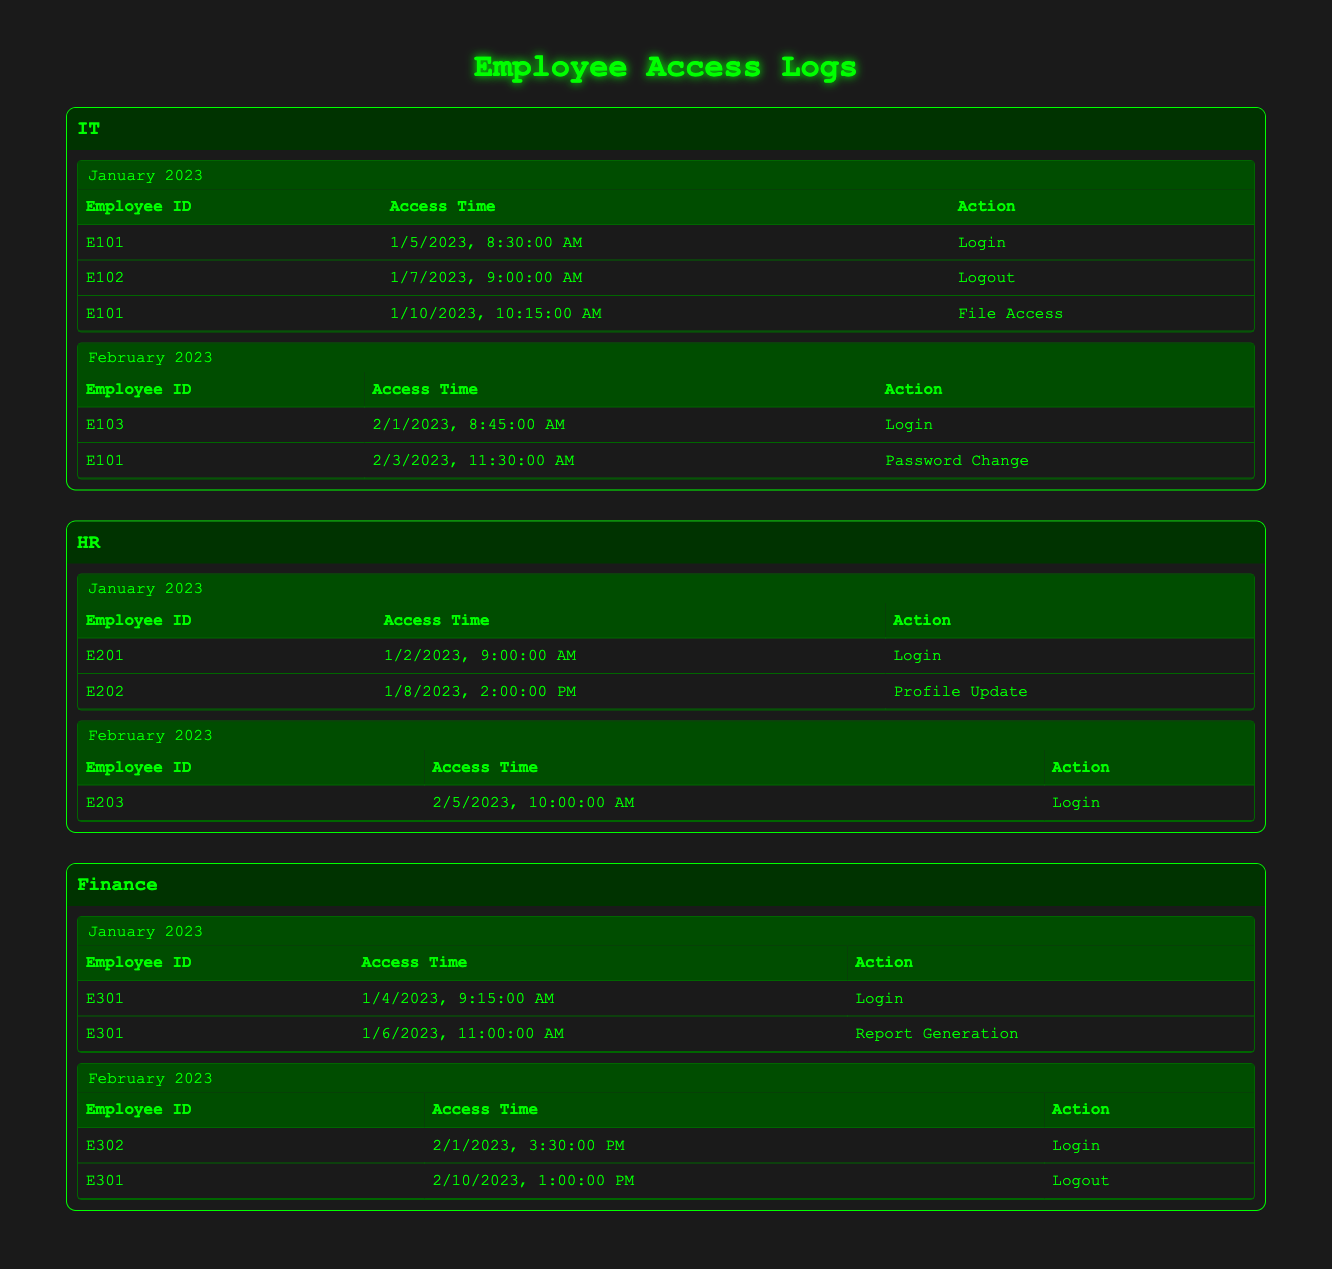What actions did Employee E101 perform in January 2023? In January 2023, Employee E101 performed three actions: on January 5, E101 logged in, on January 10, E101 accessed a file, and on January 7, E101 went offline (Logout).
Answer: Login, File Access, Logout How many logins occurred in February 2023 across all departments? In February 2023, there were three logins: E103 in IT (February 1), E203 in HR (February 5), and E302 in Finance (February 1).
Answer: 3 Did Employee E301 perform any actions in February 2023? Yes, E301 logged out on February 10, 2023, after logging in again on February 1. Therefore, E301 was active in February.
Answer: Yes Which department had the most employee activities recorded in January 2023? In January 2023, the IT department recorded three activities, HR recorded two activities, and Finance recorded two activities. Therefore, IT had the most activities.
Answer: IT How many different employees logged in during January 2023 across all departments? The total number of unique employees who logged in during January 2023 includes E101 (IT), E201 (HR), and E301 (Finance), leading to three unique employees who logged in.
Answer: 3 What were the actions performed by Employee E202 in January 2023? Employee E202 only performed the action of updating their profile on January 8, 2023.
Answer: Profile Update Was there any employee who logged out in January 2023? Yes, E102 logged out on January 7, 2023, as recorded in the IT department's logs.
Answer: Yes Which month had the least number of access entries in the HR department? In February 2023, the HR department had only one access entry recorded (E203 logged in on February 5), which is fewer than January 2023's two entries.
Answer: February 2023 How many total actions were performed by Employee E301 in January 2023? Employee E301 performed two actions in January 2023: logged in on January 4 and generated a report on January 6, totaling two actions.
Answer: 2 